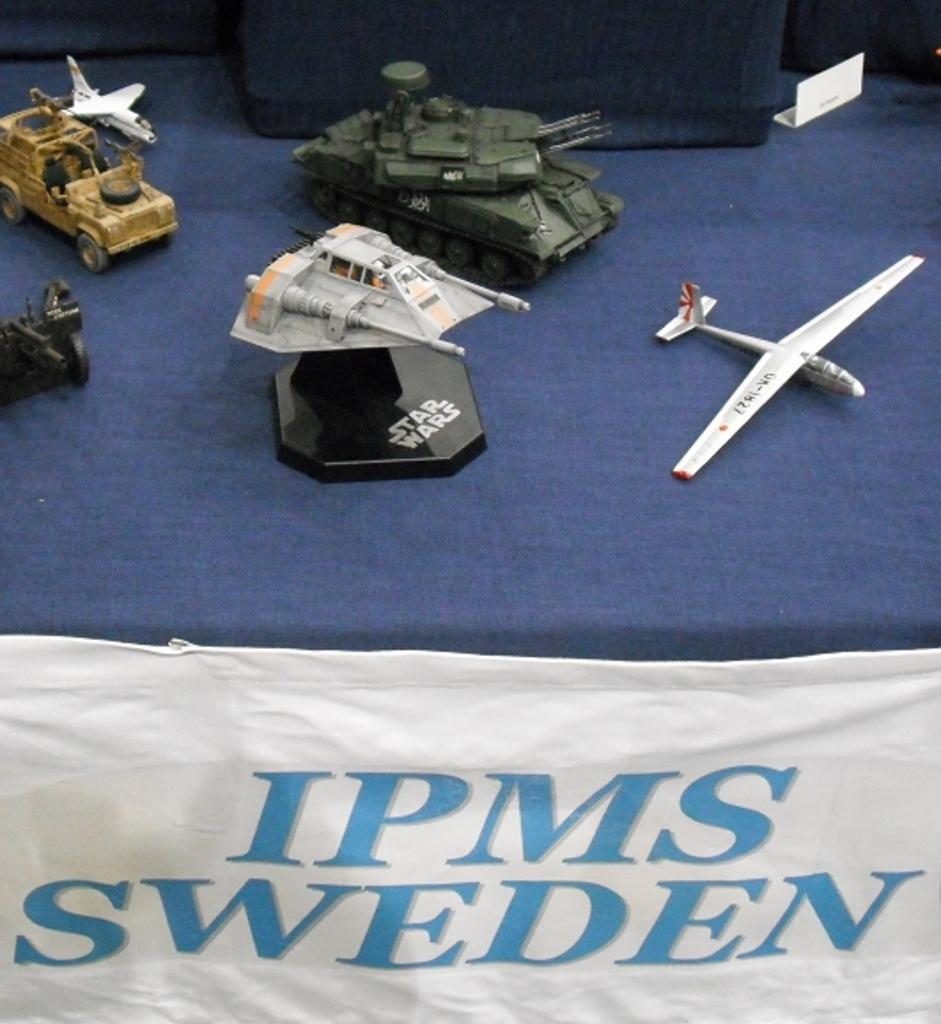What type of objects are present in the image? There are toy vehicles in the image. Where are the toy vehicles located? The toy vehicles are on an object. What other item can be seen in the image? There is a cloth in the image. What type of glove is being used to hammer the milk in the image? There is no glove, hammer, or milk present in the image. 